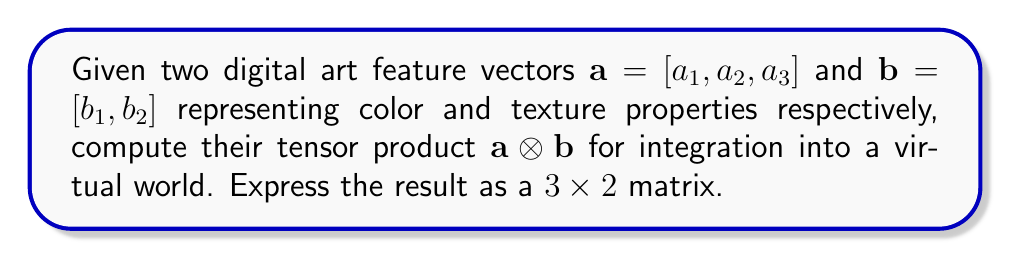Provide a solution to this math problem. To compute the tensor product of two vectors, we follow these steps:

1) The tensor product $\mathbf{a} \otimes \mathbf{b}$ results in a matrix where each element is the product of an element from $\mathbf{a}$ with an element from $\mathbf{b}$.

2) The resulting matrix will have dimensions $3 \times 2$, as $\mathbf{a}$ has 3 elements and $\mathbf{b}$ has 2 elements.

3) We compute each element of the resulting matrix:

   $(\mathbf{a} \otimes \mathbf{b})_{ij} = a_i b_j$

4) Explicitly, we calculate:

   $(\mathbf{a} \otimes \mathbf{b})_{11} = a_1 b_1$
   $(\mathbf{a} \otimes \mathbf{b})_{12} = a_1 b_2$
   $(\mathbf{a} \otimes \mathbf{b})_{21} = a_2 b_1$
   $(\mathbf{a} \otimes \mathbf{b})_{22} = a_2 b_2$
   $(\mathbf{a} \otimes \mathbf{b})_{31} = a_3 b_1$
   $(\mathbf{a} \otimes \mathbf{b})_{32} = a_3 b_2$

5) We arrange these elements into a $3 \times 2$ matrix:

   $$\mathbf{a} \otimes \mathbf{b} = \begin{bmatrix}
   a_1 b_1 & a_1 b_2 \\
   a_2 b_1 & a_2 b_2 \\
   a_3 b_1 & a_3 b_2
   \end{bmatrix}$$

This resulting matrix represents the combined feature space of color and texture properties, which can be used for integrating the digital art into a virtual world.
Answer: $$\begin{bmatrix}
a_1 b_1 & a_1 b_2 \\
a_2 b_1 & a_2 b_2 \\
a_3 b_1 & a_3 b_2
\end{bmatrix}$$ 